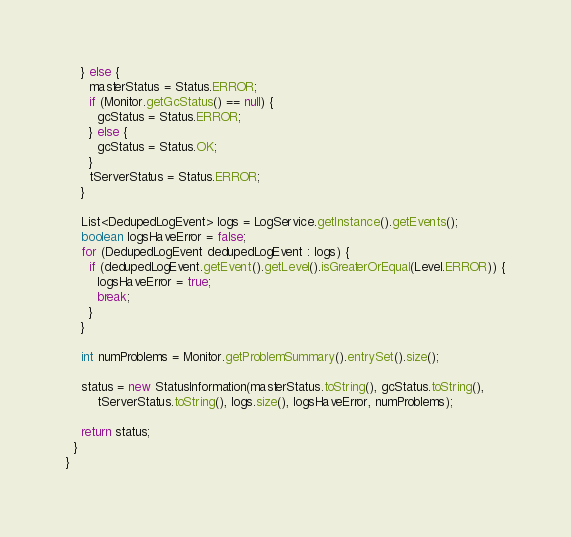Convert code to text. <code><loc_0><loc_0><loc_500><loc_500><_Java_>    } else {
      masterStatus = Status.ERROR;
      if (Monitor.getGcStatus() == null) {
        gcStatus = Status.ERROR;
      } else {
        gcStatus = Status.OK;
      }
      tServerStatus = Status.ERROR;
    }

    List<DedupedLogEvent> logs = LogService.getInstance().getEvents();
    boolean logsHaveError = false;
    for (DedupedLogEvent dedupedLogEvent : logs) {
      if (dedupedLogEvent.getEvent().getLevel().isGreaterOrEqual(Level.ERROR)) {
        logsHaveError = true;
        break;
      }
    }

    int numProblems = Monitor.getProblemSummary().entrySet().size();

    status = new StatusInformation(masterStatus.toString(), gcStatus.toString(),
        tServerStatus.toString(), logs.size(), logsHaveError, numProblems);

    return status;
  }
}
</code> 